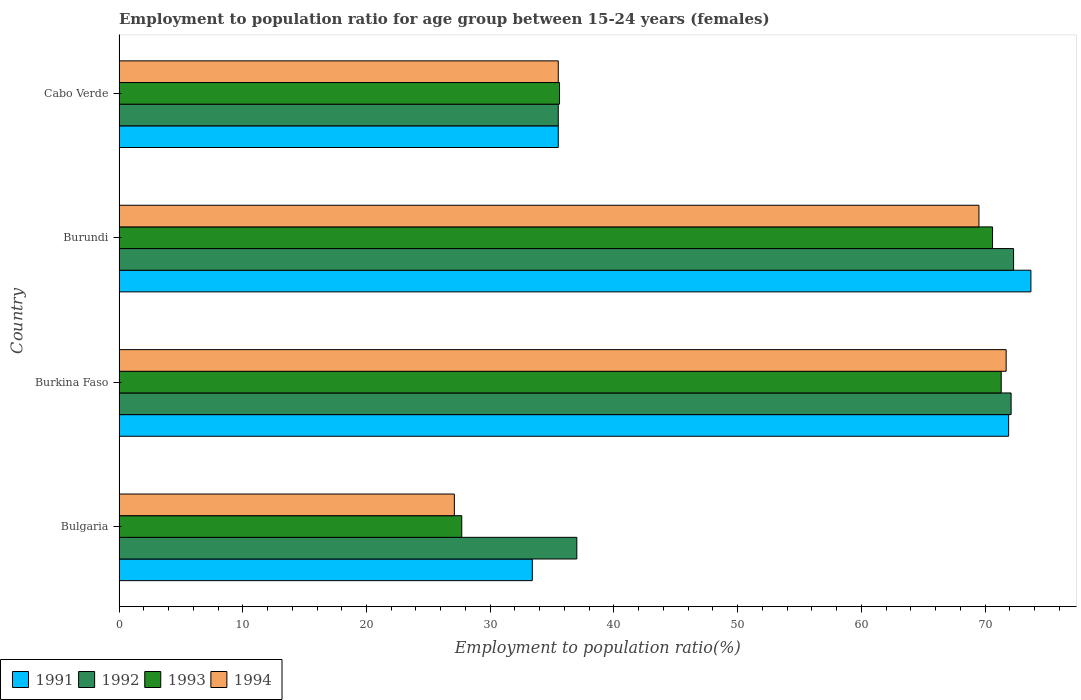Are the number of bars on each tick of the Y-axis equal?
Provide a succinct answer. Yes. How many bars are there on the 3rd tick from the top?
Offer a very short reply. 4. What is the label of the 1st group of bars from the top?
Provide a short and direct response. Cabo Verde. In how many cases, is the number of bars for a given country not equal to the number of legend labels?
Provide a short and direct response. 0. What is the employment to population ratio in 1994 in Burkina Faso?
Provide a succinct answer. 71.7. Across all countries, what is the maximum employment to population ratio in 1991?
Offer a very short reply. 73.7. Across all countries, what is the minimum employment to population ratio in 1991?
Your answer should be very brief. 33.4. In which country was the employment to population ratio in 1993 maximum?
Provide a succinct answer. Burkina Faso. In which country was the employment to population ratio in 1991 minimum?
Offer a very short reply. Bulgaria. What is the total employment to population ratio in 1993 in the graph?
Your answer should be very brief. 205.2. What is the difference between the employment to population ratio in 1991 in Burundi and that in Cabo Verde?
Your response must be concise. 38.2. What is the difference between the employment to population ratio in 1992 in Burundi and the employment to population ratio in 1994 in Bulgaria?
Ensure brevity in your answer.  45.2. What is the average employment to population ratio in 1993 per country?
Provide a short and direct response. 51.3. What is the difference between the employment to population ratio in 1992 and employment to population ratio in 1994 in Burundi?
Your answer should be very brief. 2.8. In how many countries, is the employment to population ratio in 1992 greater than 26 %?
Your answer should be very brief. 4. What is the ratio of the employment to population ratio in 1992 in Burundi to that in Cabo Verde?
Offer a very short reply. 2.04. What is the difference between the highest and the second highest employment to population ratio in 1993?
Provide a short and direct response. 0.7. What is the difference between the highest and the lowest employment to population ratio in 1992?
Your answer should be very brief. 36.8. Is the sum of the employment to population ratio in 1992 in Bulgaria and Burkina Faso greater than the maximum employment to population ratio in 1994 across all countries?
Your answer should be very brief. Yes. Is it the case that in every country, the sum of the employment to population ratio in 1991 and employment to population ratio in 1994 is greater than the sum of employment to population ratio in 1993 and employment to population ratio in 1992?
Keep it short and to the point. No. How many countries are there in the graph?
Give a very brief answer. 4. Are the values on the major ticks of X-axis written in scientific E-notation?
Offer a terse response. No. Does the graph contain any zero values?
Give a very brief answer. No. Where does the legend appear in the graph?
Offer a very short reply. Bottom left. What is the title of the graph?
Ensure brevity in your answer.  Employment to population ratio for age group between 15-24 years (females). Does "1964" appear as one of the legend labels in the graph?
Give a very brief answer. No. What is the label or title of the X-axis?
Your response must be concise. Employment to population ratio(%). What is the Employment to population ratio(%) in 1991 in Bulgaria?
Make the answer very short. 33.4. What is the Employment to population ratio(%) in 1993 in Bulgaria?
Your answer should be very brief. 27.7. What is the Employment to population ratio(%) of 1994 in Bulgaria?
Your answer should be compact. 27.1. What is the Employment to population ratio(%) in 1991 in Burkina Faso?
Offer a very short reply. 71.9. What is the Employment to population ratio(%) of 1992 in Burkina Faso?
Offer a very short reply. 72.1. What is the Employment to population ratio(%) in 1993 in Burkina Faso?
Offer a terse response. 71.3. What is the Employment to population ratio(%) of 1994 in Burkina Faso?
Provide a short and direct response. 71.7. What is the Employment to population ratio(%) of 1991 in Burundi?
Give a very brief answer. 73.7. What is the Employment to population ratio(%) of 1992 in Burundi?
Your answer should be very brief. 72.3. What is the Employment to population ratio(%) of 1993 in Burundi?
Ensure brevity in your answer.  70.6. What is the Employment to population ratio(%) in 1994 in Burundi?
Offer a terse response. 69.5. What is the Employment to population ratio(%) in 1991 in Cabo Verde?
Your answer should be compact. 35.5. What is the Employment to population ratio(%) in 1992 in Cabo Verde?
Make the answer very short. 35.5. What is the Employment to population ratio(%) in 1993 in Cabo Verde?
Your response must be concise. 35.6. What is the Employment to population ratio(%) in 1994 in Cabo Verde?
Your answer should be compact. 35.5. Across all countries, what is the maximum Employment to population ratio(%) in 1991?
Keep it short and to the point. 73.7. Across all countries, what is the maximum Employment to population ratio(%) in 1992?
Make the answer very short. 72.3. Across all countries, what is the maximum Employment to population ratio(%) of 1993?
Offer a terse response. 71.3. Across all countries, what is the maximum Employment to population ratio(%) of 1994?
Give a very brief answer. 71.7. Across all countries, what is the minimum Employment to population ratio(%) of 1991?
Offer a terse response. 33.4. Across all countries, what is the minimum Employment to population ratio(%) in 1992?
Your answer should be compact. 35.5. Across all countries, what is the minimum Employment to population ratio(%) of 1993?
Your response must be concise. 27.7. Across all countries, what is the minimum Employment to population ratio(%) of 1994?
Your response must be concise. 27.1. What is the total Employment to population ratio(%) of 1991 in the graph?
Give a very brief answer. 214.5. What is the total Employment to population ratio(%) in 1992 in the graph?
Ensure brevity in your answer.  216.9. What is the total Employment to population ratio(%) of 1993 in the graph?
Offer a very short reply. 205.2. What is the total Employment to population ratio(%) in 1994 in the graph?
Ensure brevity in your answer.  203.8. What is the difference between the Employment to population ratio(%) of 1991 in Bulgaria and that in Burkina Faso?
Provide a short and direct response. -38.5. What is the difference between the Employment to population ratio(%) in 1992 in Bulgaria and that in Burkina Faso?
Your response must be concise. -35.1. What is the difference between the Employment to population ratio(%) of 1993 in Bulgaria and that in Burkina Faso?
Your response must be concise. -43.6. What is the difference between the Employment to population ratio(%) in 1994 in Bulgaria and that in Burkina Faso?
Give a very brief answer. -44.6. What is the difference between the Employment to population ratio(%) of 1991 in Bulgaria and that in Burundi?
Provide a succinct answer. -40.3. What is the difference between the Employment to population ratio(%) of 1992 in Bulgaria and that in Burundi?
Make the answer very short. -35.3. What is the difference between the Employment to population ratio(%) of 1993 in Bulgaria and that in Burundi?
Keep it short and to the point. -42.9. What is the difference between the Employment to population ratio(%) in 1994 in Bulgaria and that in Burundi?
Make the answer very short. -42.4. What is the difference between the Employment to population ratio(%) of 1992 in Bulgaria and that in Cabo Verde?
Your answer should be very brief. 1.5. What is the difference between the Employment to population ratio(%) in 1993 in Bulgaria and that in Cabo Verde?
Your answer should be compact. -7.9. What is the difference between the Employment to population ratio(%) of 1994 in Bulgaria and that in Cabo Verde?
Keep it short and to the point. -8.4. What is the difference between the Employment to population ratio(%) in 1993 in Burkina Faso and that in Burundi?
Offer a terse response. 0.7. What is the difference between the Employment to population ratio(%) in 1991 in Burkina Faso and that in Cabo Verde?
Provide a succinct answer. 36.4. What is the difference between the Employment to population ratio(%) of 1992 in Burkina Faso and that in Cabo Verde?
Keep it short and to the point. 36.6. What is the difference between the Employment to population ratio(%) in 1993 in Burkina Faso and that in Cabo Verde?
Provide a succinct answer. 35.7. What is the difference between the Employment to population ratio(%) in 1994 in Burkina Faso and that in Cabo Verde?
Your answer should be compact. 36.2. What is the difference between the Employment to population ratio(%) in 1991 in Burundi and that in Cabo Verde?
Your answer should be very brief. 38.2. What is the difference between the Employment to population ratio(%) of 1992 in Burundi and that in Cabo Verde?
Your answer should be compact. 36.8. What is the difference between the Employment to population ratio(%) in 1993 in Burundi and that in Cabo Verde?
Provide a short and direct response. 35. What is the difference between the Employment to population ratio(%) in 1991 in Bulgaria and the Employment to population ratio(%) in 1992 in Burkina Faso?
Ensure brevity in your answer.  -38.7. What is the difference between the Employment to population ratio(%) of 1991 in Bulgaria and the Employment to population ratio(%) of 1993 in Burkina Faso?
Ensure brevity in your answer.  -37.9. What is the difference between the Employment to population ratio(%) of 1991 in Bulgaria and the Employment to population ratio(%) of 1994 in Burkina Faso?
Provide a short and direct response. -38.3. What is the difference between the Employment to population ratio(%) in 1992 in Bulgaria and the Employment to population ratio(%) in 1993 in Burkina Faso?
Your response must be concise. -34.3. What is the difference between the Employment to population ratio(%) of 1992 in Bulgaria and the Employment to population ratio(%) of 1994 in Burkina Faso?
Give a very brief answer. -34.7. What is the difference between the Employment to population ratio(%) in 1993 in Bulgaria and the Employment to population ratio(%) in 1994 in Burkina Faso?
Give a very brief answer. -44. What is the difference between the Employment to population ratio(%) of 1991 in Bulgaria and the Employment to population ratio(%) of 1992 in Burundi?
Offer a terse response. -38.9. What is the difference between the Employment to population ratio(%) in 1991 in Bulgaria and the Employment to population ratio(%) in 1993 in Burundi?
Your response must be concise. -37.2. What is the difference between the Employment to population ratio(%) of 1991 in Bulgaria and the Employment to population ratio(%) of 1994 in Burundi?
Keep it short and to the point. -36.1. What is the difference between the Employment to population ratio(%) of 1992 in Bulgaria and the Employment to population ratio(%) of 1993 in Burundi?
Your answer should be compact. -33.6. What is the difference between the Employment to population ratio(%) in 1992 in Bulgaria and the Employment to population ratio(%) in 1994 in Burundi?
Your answer should be compact. -32.5. What is the difference between the Employment to population ratio(%) in 1993 in Bulgaria and the Employment to population ratio(%) in 1994 in Burundi?
Your answer should be very brief. -41.8. What is the difference between the Employment to population ratio(%) in 1991 in Bulgaria and the Employment to population ratio(%) in 1992 in Cabo Verde?
Keep it short and to the point. -2.1. What is the difference between the Employment to population ratio(%) of 1991 in Bulgaria and the Employment to population ratio(%) of 1993 in Cabo Verde?
Your answer should be compact. -2.2. What is the difference between the Employment to population ratio(%) in 1991 in Bulgaria and the Employment to population ratio(%) in 1994 in Cabo Verde?
Offer a very short reply. -2.1. What is the difference between the Employment to population ratio(%) of 1992 in Bulgaria and the Employment to population ratio(%) of 1993 in Cabo Verde?
Provide a succinct answer. 1.4. What is the difference between the Employment to population ratio(%) of 1993 in Bulgaria and the Employment to population ratio(%) of 1994 in Cabo Verde?
Offer a very short reply. -7.8. What is the difference between the Employment to population ratio(%) in 1991 in Burkina Faso and the Employment to population ratio(%) in 1992 in Burundi?
Your answer should be very brief. -0.4. What is the difference between the Employment to population ratio(%) in 1991 in Burkina Faso and the Employment to population ratio(%) in 1993 in Burundi?
Provide a succinct answer. 1.3. What is the difference between the Employment to population ratio(%) in 1991 in Burkina Faso and the Employment to population ratio(%) in 1994 in Burundi?
Keep it short and to the point. 2.4. What is the difference between the Employment to population ratio(%) in 1992 in Burkina Faso and the Employment to population ratio(%) in 1993 in Burundi?
Give a very brief answer. 1.5. What is the difference between the Employment to population ratio(%) of 1992 in Burkina Faso and the Employment to population ratio(%) of 1994 in Burundi?
Your response must be concise. 2.6. What is the difference between the Employment to population ratio(%) of 1993 in Burkina Faso and the Employment to population ratio(%) of 1994 in Burundi?
Provide a short and direct response. 1.8. What is the difference between the Employment to population ratio(%) of 1991 in Burkina Faso and the Employment to population ratio(%) of 1992 in Cabo Verde?
Your answer should be compact. 36.4. What is the difference between the Employment to population ratio(%) in 1991 in Burkina Faso and the Employment to population ratio(%) in 1993 in Cabo Verde?
Ensure brevity in your answer.  36.3. What is the difference between the Employment to population ratio(%) of 1991 in Burkina Faso and the Employment to population ratio(%) of 1994 in Cabo Verde?
Your answer should be very brief. 36.4. What is the difference between the Employment to population ratio(%) of 1992 in Burkina Faso and the Employment to population ratio(%) of 1993 in Cabo Verde?
Give a very brief answer. 36.5. What is the difference between the Employment to population ratio(%) in 1992 in Burkina Faso and the Employment to population ratio(%) in 1994 in Cabo Verde?
Provide a short and direct response. 36.6. What is the difference between the Employment to population ratio(%) of 1993 in Burkina Faso and the Employment to population ratio(%) of 1994 in Cabo Verde?
Keep it short and to the point. 35.8. What is the difference between the Employment to population ratio(%) in 1991 in Burundi and the Employment to population ratio(%) in 1992 in Cabo Verde?
Your answer should be compact. 38.2. What is the difference between the Employment to population ratio(%) of 1991 in Burundi and the Employment to population ratio(%) of 1993 in Cabo Verde?
Provide a short and direct response. 38.1. What is the difference between the Employment to population ratio(%) of 1991 in Burundi and the Employment to population ratio(%) of 1994 in Cabo Verde?
Provide a short and direct response. 38.2. What is the difference between the Employment to population ratio(%) of 1992 in Burundi and the Employment to population ratio(%) of 1993 in Cabo Verde?
Your response must be concise. 36.7. What is the difference between the Employment to population ratio(%) of 1992 in Burundi and the Employment to population ratio(%) of 1994 in Cabo Verde?
Your answer should be compact. 36.8. What is the difference between the Employment to population ratio(%) in 1993 in Burundi and the Employment to population ratio(%) in 1994 in Cabo Verde?
Provide a short and direct response. 35.1. What is the average Employment to population ratio(%) of 1991 per country?
Give a very brief answer. 53.62. What is the average Employment to population ratio(%) in 1992 per country?
Your answer should be very brief. 54.23. What is the average Employment to population ratio(%) of 1993 per country?
Your response must be concise. 51.3. What is the average Employment to population ratio(%) of 1994 per country?
Ensure brevity in your answer.  50.95. What is the difference between the Employment to population ratio(%) of 1991 and Employment to population ratio(%) of 1993 in Bulgaria?
Offer a very short reply. 5.7. What is the difference between the Employment to population ratio(%) of 1992 and Employment to population ratio(%) of 1993 in Bulgaria?
Your answer should be compact. 9.3. What is the difference between the Employment to population ratio(%) in 1991 and Employment to population ratio(%) in 1992 in Burkina Faso?
Provide a succinct answer. -0.2. What is the difference between the Employment to population ratio(%) in 1991 and Employment to population ratio(%) in 1994 in Burkina Faso?
Offer a terse response. 0.2. What is the difference between the Employment to population ratio(%) in 1992 and Employment to population ratio(%) in 1993 in Burkina Faso?
Provide a succinct answer. 0.8. What is the difference between the Employment to population ratio(%) of 1992 and Employment to population ratio(%) of 1994 in Burkina Faso?
Your response must be concise. 0.4. What is the difference between the Employment to population ratio(%) of 1991 and Employment to population ratio(%) of 1992 in Burundi?
Ensure brevity in your answer.  1.4. What is the difference between the Employment to population ratio(%) in 1992 and Employment to population ratio(%) in 1993 in Burundi?
Offer a very short reply. 1.7. What is the difference between the Employment to population ratio(%) of 1992 and Employment to population ratio(%) of 1994 in Burundi?
Offer a very short reply. 2.8. What is the difference between the Employment to population ratio(%) of 1991 and Employment to population ratio(%) of 1994 in Cabo Verde?
Your response must be concise. 0. What is the difference between the Employment to population ratio(%) of 1992 and Employment to population ratio(%) of 1993 in Cabo Verde?
Make the answer very short. -0.1. What is the ratio of the Employment to population ratio(%) of 1991 in Bulgaria to that in Burkina Faso?
Offer a terse response. 0.46. What is the ratio of the Employment to population ratio(%) in 1992 in Bulgaria to that in Burkina Faso?
Provide a succinct answer. 0.51. What is the ratio of the Employment to population ratio(%) in 1993 in Bulgaria to that in Burkina Faso?
Ensure brevity in your answer.  0.39. What is the ratio of the Employment to population ratio(%) in 1994 in Bulgaria to that in Burkina Faso?
Ensure brevity in your answer.  0.38. What is the ratio of the Employment to population ratio(%) of 1991 in Bulgaria to that in Burundi?
Ensure brevity in your answer.  0.45. What is the ratio of the Employment to population ratio(%) of 1992 in Bulgaria to that in Burundi?
Make the answer very short. 0.51. What is the ratio of the Employment to population ratio(%) in 1993 in Bulgaria to that in Burundi?
Keep it short and to the point. 0.39. What is the ratio of the Employment to population ratio(%) of 1994 in Bulgaria to that in Burundi?
Make the answer very short. 0.39. What is the ratio of the Employment to population ratio(%) in 1991 in Bulgaria to that in Cabo Verde?
Offer a very short reply. 0.94. What is the ratio of the Employment to population ratio(%) in 1992 in Bulgaria to that in Cabo Verde?
Provide a succinct answer. 1.04. What is the ratio of the Employment to population ratio(%) of 1993 in Bulgaria to that in Cabo Verde?
Offer a terse response. 0.78. What is the ratio of the Employment to population ratio(%) of 1994 in Bulgaria to that in Cabo Verde?
Your answer should be very brief. 0.76. What is the ratio of the Employment to population ratio(%) in 1991 in Burkina Faso to that in Burundi?
Your answer should be compact. 0.98. What is the ratio of the Employment to population ratio(%) in 1993 in Burkina Faso to that in Burundi?
Your answer should be very brief. 1.01. What is the ratio of the Employment to population ratio(%) in 1994 in Burkina Faso to that in Burundi?
Keep it short and to the point. 1.03. What is the ratio of the Employment to population ratio(%) of 1991 in Burkina Faso to that in Cabo Verde?
Keep it short and to the point. 2.03. What is the ratio of the Employment to population ratio(%) of 1992 in Burkina Faso to that in Cabo Verde?
Offer a terse response. 2.03. What is the ratio of the Employment to population ratio(%) in 1993 in Burkina Faso to that in Cabo Verde?
Ensure brevity in your answer.  2. What is the ratio of the Employment to population ratio(%) of 1994 in Burkina Faso to that in Cabo Verde?
Ensure brevity in your answer.  2.02. What is the ratio of the Employment to population ratio(%) in 1991 in Burundi to that in Cabo Verde?
Make the answer very short. 2.08. What is the ratio of the Employment to population ratio(%) in 1992 in Burundi to that in Cabo Verde?
Keep it short and to the point. 2.04. What is the ratio of the Employment to population ratio(%) in 1993 in Burundi to that in Cabo Verde?
Offer a very short reply. 1.98. What is the ratio of the Employment to population ratio(%) in 1994 in Burundi to that in Cabo Verde?
Give a very brief answer. 1.96. What is the difference between the highest and the second highest Employment to population ratio(%) in 1991?
Ensure brevity in your answer.  1.8. What is the difference between the highest and the second highest Employment to population ratio(%) in 1993?
Provide a short and direct response. 0.7. What is the difference between the highest and the lowest Employment to population ratio(%) in 1991?
Keep it short and to the point. 40.3. What is the difference between the highest and the lowest Employment to population ratio(%) in 1992?
Your answer should be compact. 36.8. What is the difference between the highest and the lowest Employment to population ratio(%) in 1993?
Your response must be concise. 43.6. What is the difference between the highest and the lowest Employment to population ratio(%) of 1994?
Provide a succinct answer. 44.6. 